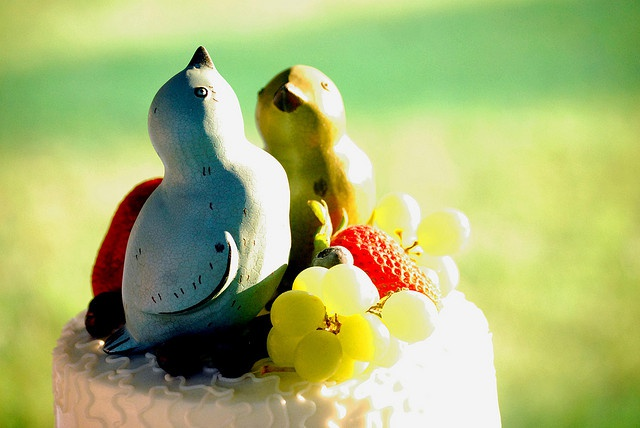Describe the objects in this image and their specific colors. I can see cake in khaki, white, black, gray, and teal tones, bird in khaki, teal, gray, white, and black tones, and bird in khaki, olive, ivory, and black tones in this image. 